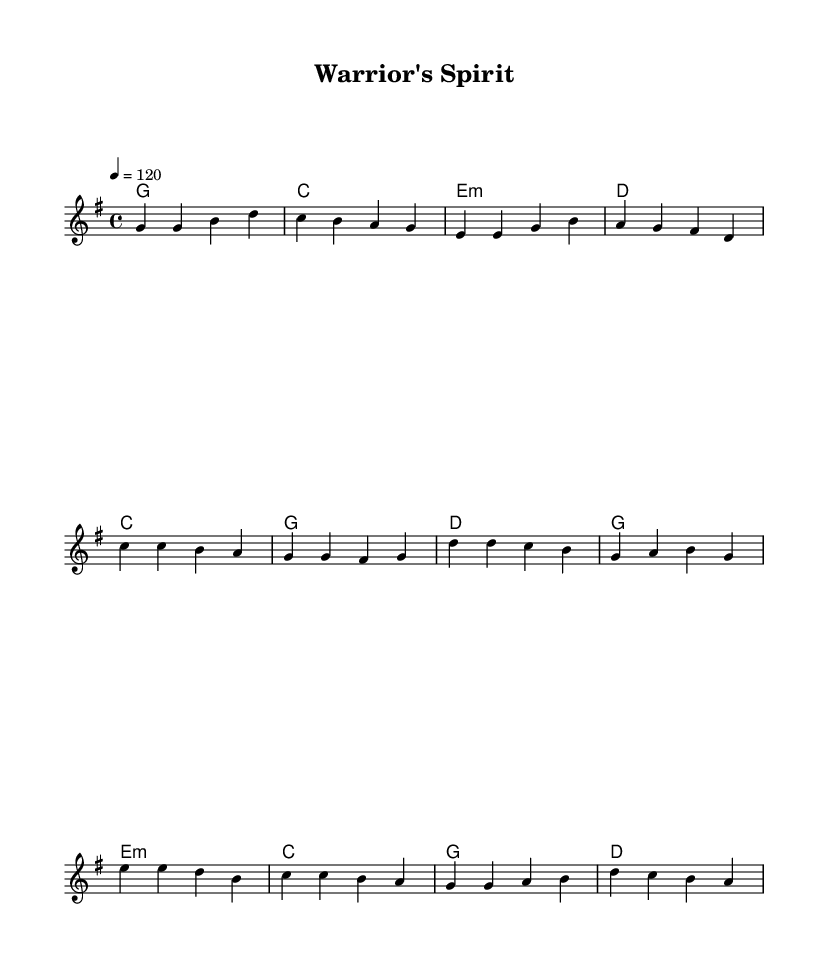What is the key signature of this music? The key signature is G major, which is indicated by one sharp (F#).
Answer: G major What is the time signature of this music? The time signature is 4/4, meaning there are four beats per measure and the quarter note gets one beat.
Answer: 4/4 What is the tempo marking of this piece? The tempo marking indicates a speed of 120 beats per minute, specified in the music as "4 = 120".
Answer: 120 How many measures are in the verse section? The verse consists of four measures, which can be counted from the melody lines written for that section.
Answer: 4 What is the starting note of the chorus? The chorus starts on the note C, as indicated by the melody line at the beginning of that section.
Answer: C Which chord is used in the bridge section? The bridge features several chords, one of which is an E minor chord, shown in the harmonies section of the score.
Answer: E minor What is a defining topic in the lyrics of this country rock song? The song explores themes of resilience and overcoming adversity, which are characteristic of the country rock genre.
Answer: Resilience 